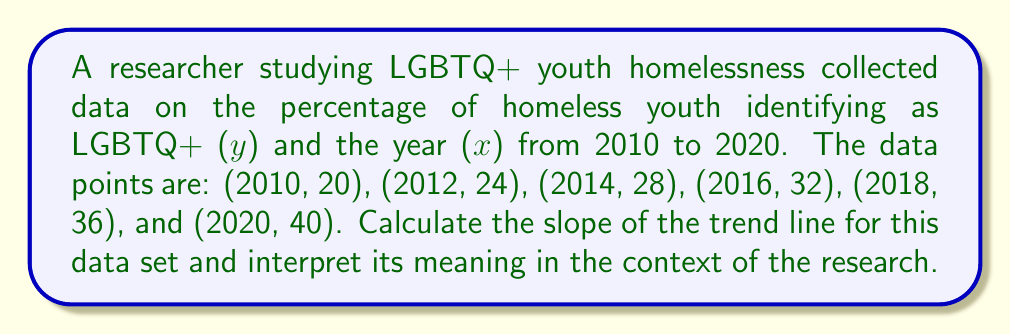Give your solution to this math problem. To calculate the slope of the trend line, we'll use the formula for the slope of a linear regression line:

$$m = \frac{n\sum xy - \sum x \sum y}{n\sum x^2 - (\sum x)^2}$$

Where:
$n$ is the number of data points
$x$ represents the years
$y$ represents the percentage of homeless youth identifying as LGBTQ+

Step 1: Calculate the necessary sums:
$n = 6$
$\sum x = 2010 + 2012 + 2014 + 2016 + 2018 + 2020 = 12090$
$\sum y = 20 + 24 + 28 + 32 + 36 + 40 = 180$
$\sum xy = (2010 \cdot 20) + (2012 \cdot 24) + (2014 \cdot 28) + (2016 \cdot 32) + (2018 \cdot 36) + (2020 \cdot 40) = 363240$
$\sum x^2 = 2010^2 + 2012^2 + 2014^2 + 2016^2 + 2018^2 + 2020^2 = 24361890$

Step 2: Substitute these values into the slope formula:

$$m = \frac{6(363240) - (12090)(180)}{6(24361890) - (12090)^2}$$

Step 3: Simplify:

$$m = \frac{2179440 - 2176200}{146171340 - 146168100} = \frac{3240}{3240} = 1$$

Step 4: Interpret the result:
The slope of 1 indicates that for each year increase, the percentage of homeless youth identifying as LGBTQ+ increases by 1 percentage point. This suggests a steady annual increase in the proportion of LGBTQ+ youth among the homeless youth population over the studied period.
Answer: 1 percentage point increase per year 